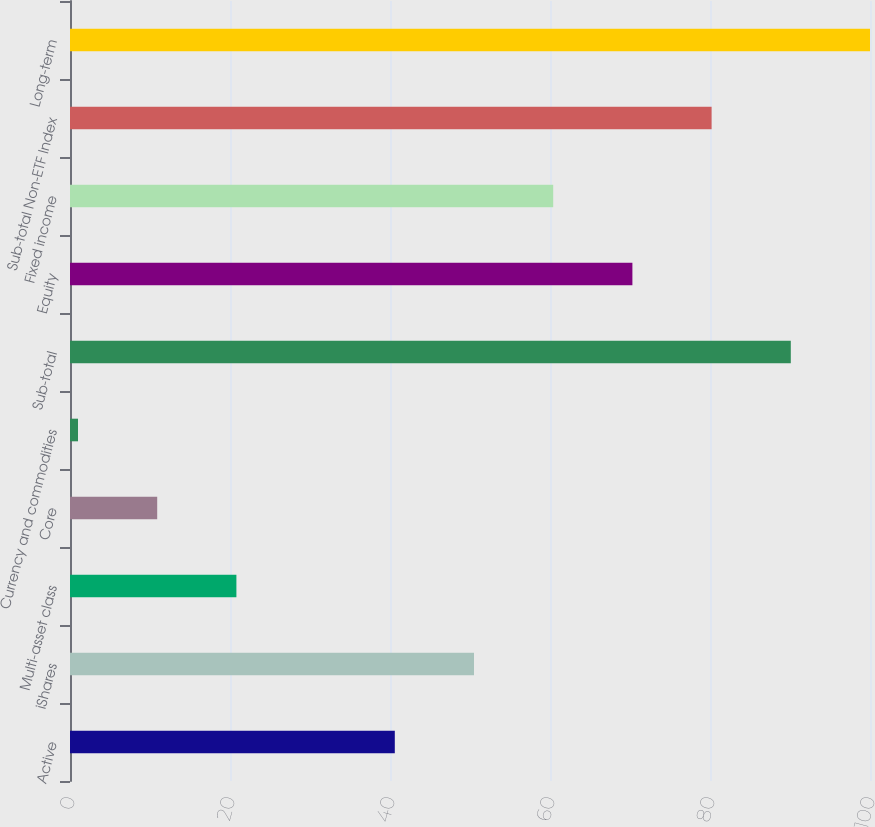Convert chart to OTSL. <chart><loc_0><loc_0><loc_500><loc_500><bar_chart><fcel>Active<fcel>iShares<fcel>Multi-asset class<fcel>Core<fcel>Currency and commodities<fcel>Sub-total<fcel>Equity<fcel>Fixed income<fcel>Sub-total Non-ETF Index<fcel>Long-term<nl><fcel>40.6<fcel>50.5<fcel>20.8<fcel>10.9<fcel>1<fcel>90.1<fcel>70.3<fcel>60.4<fcel>80.2<fcel>100<nl></chart> 